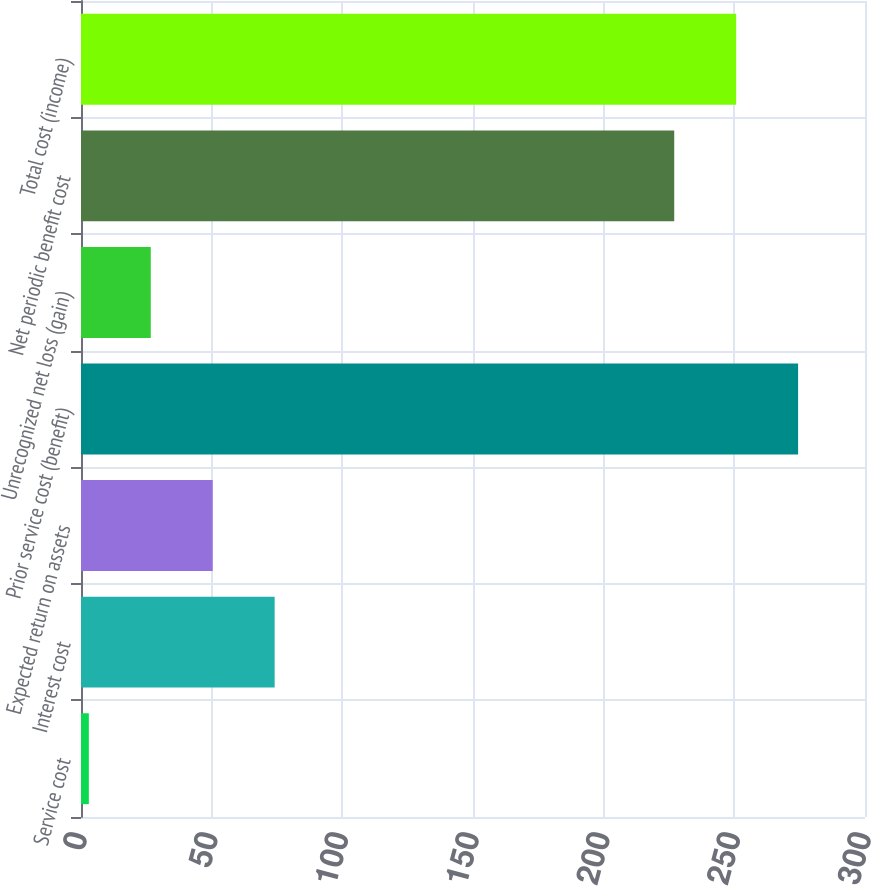Convert chart to OTSL. <chart><loc_0><loc_0><loc_500><loc_500><bar_chart><fcel>Service cost<fcel>Interest cost<fcel>Expected return on assets<fcel>Prior service cost (benefit)<fcel>Unrecognized net loss (gain)<fcel>Net periodic benefit cost<fcel>Total cost (income)<nl><fcel>3<fcel>74.1<fcel>50.4<fcel>274.4<fcel>26.7<fcel>227<fcel>250.7<nl></chart> 